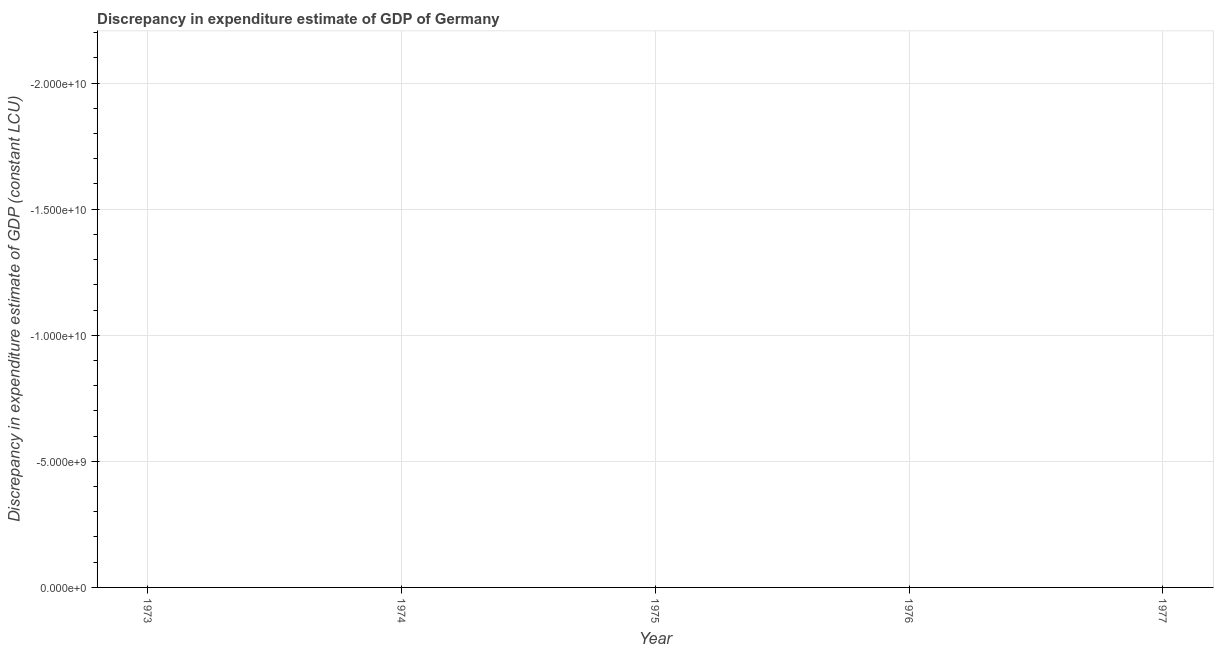What is the median discrepancy in expenditure estimate of gdp?
Make the answer very short. 0. In how many years, is the discrepancy in expenditure estimate of gdp greater than -19000000000 LCU?
Give a very brief answer. 0. In how many years, is the discrepancy in expenditure estimate of gdp greater than the average discrepancy in expenditure estimate of gdp taken over all years?
Offer a terse response. 0. How many years are there in the graph?
Make the answer very short. 5. What is the difference between two consecutive major ticks on the Y-axis?
Provide a succinct answer. 5.00e+09. Are the values on the major ticks of Y-axis written in scientific E-notation?
Offer a terse response. Yes. Does the graph contain any zero values?
Your answer should be compact. Yes. What is the title of the graph?
Offer a terse response. Discrepancy in expenditure estimate of GDP of Germany. What is the label or title of the X-axis?
Provide a short and direct response. Year. What is the label or title of the Y-axis?
Offer a very short reply. Discrepancy in expenditure estimate of GDP (constant LCU). What is the Discrepancy in expenditure estimate of GDP (constant LCU) in 1973?
Ensure brevity in your answer.  0. What is the Discrepancy in expenditure estimate of GDP (constant LCU) in 1976?
Ensure brevity in your answer.  0. 